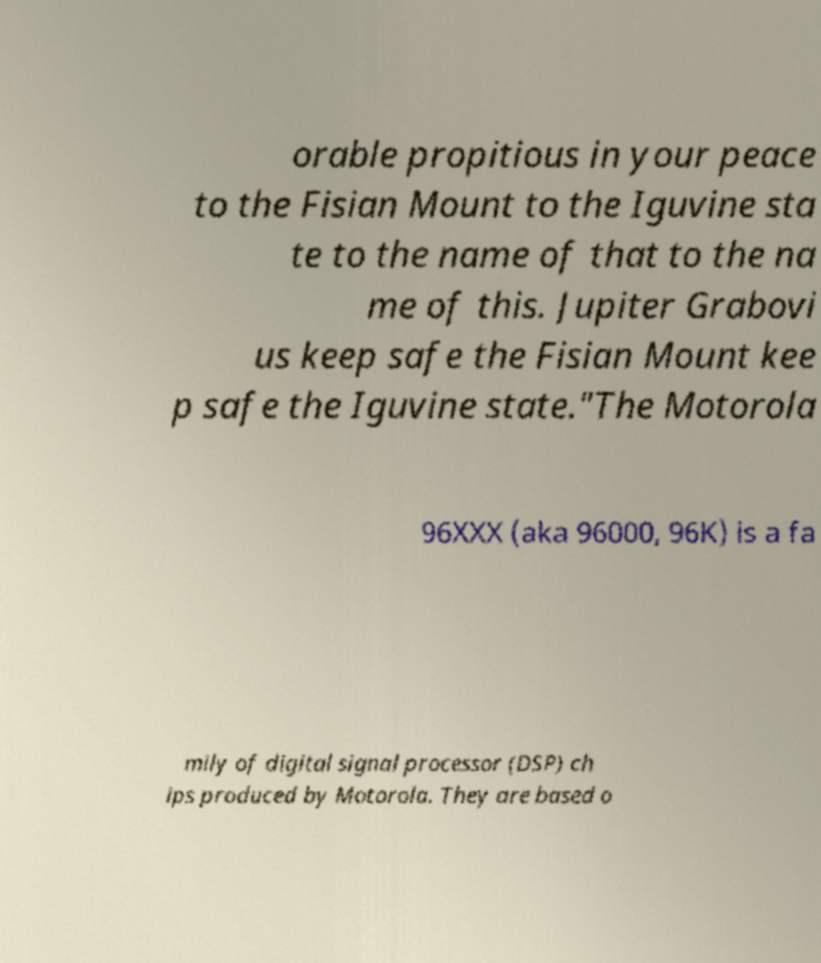What messages or text are displayed in this image? I need them in a readable, typed format. orable propitious in your peace to the Fisian Mount to the Iguvine sta te to the name of that to the na me of this. Jupiter Grabovi us keep safe the Fisian Mount kee p safe the Iguvine state."The Motorola 96XXX (aka 96000, 96K) is a fa mily of digital signal processor (DSP) ch ips produced by Motorola. They are based o 